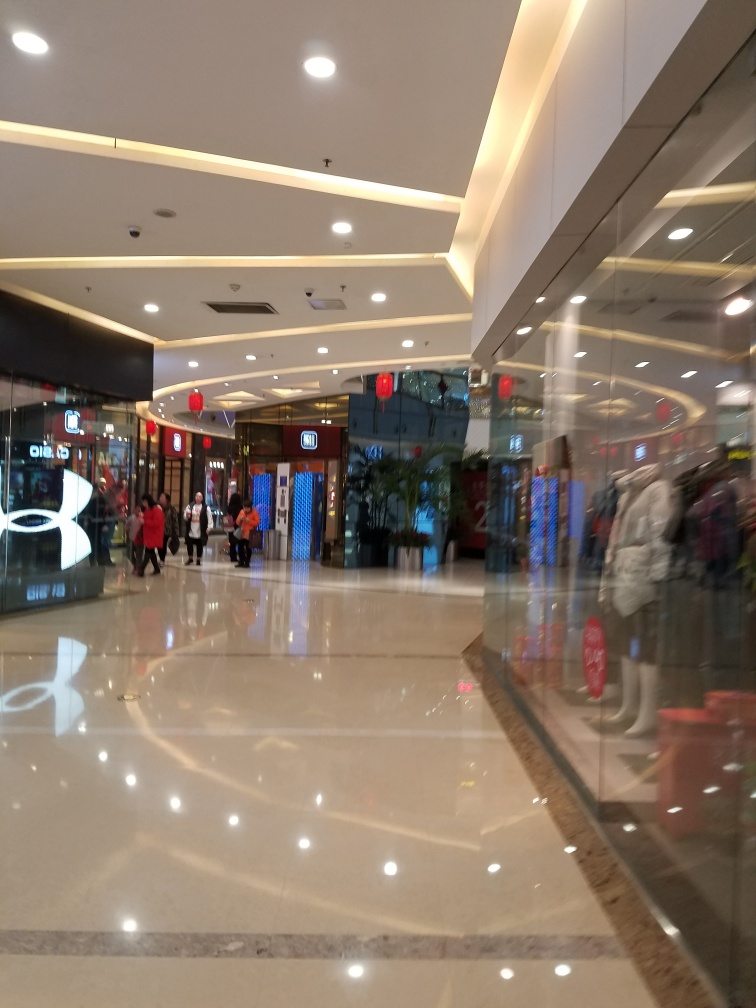Can you describe the setting depicted in the image? Certainly, the image depicts an indoor scene, specifically what appears to be a shopping mall. There are multiple stores with lit signage, and the area is spacious with a highly reflective tile flooring. The ceiling has recessed lighting, and decorations are hanging, suggesting that this might be taken during a festive season or sale period. A few shoppers can be seen walking around, adding life to the scene. 